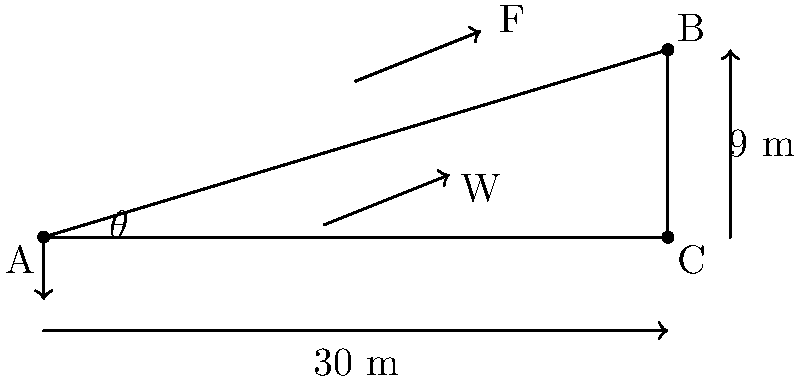You're planning to use your new tractor to plow an inclined field on your farm. The field rises 9 meters over a horizontal distance of 30 meters. Your tractor weighs 5000 kg. What minimum force (F) is required to pull the tractor up the incline at a constant speed? Assume the coefficient of friction between the tractor's wheels and the ground is 0.2, and use g = 9.8 m/s². Let's approach this step-by-step:

1) First, we need to find the angle of inclination ($\theta$):
   $\tan \theta = \frac{\text{rise}}{\text{run}} = \frac{9 \text{ m}}{30 \text{ m}} = 0.3$
   $\theta = \arctan(0.3) \approx 16.7°$

2) The weight of the tractor:
   $W = mg = 5000 \text{ kg} \times 9.8 \text{ m/s²} = 49,000 \text{ N}$

3) We can break this weight into components parallel and perpendicular to the incline:
   $W_\parallel = W \sin \theta = 49,000 \text{ N} \times \sin 16.7° \approx 14,077 \text{ N}$
   $W_\perp = W \cos \theta = 49,000 \text{ N} \times \cos 16.7° \approx 46,916 \text{ N}$

4) The friction force is:
   $f = \mu W_\perp = 0.2 \times 46,916 \text{ N} = 9,383 \text{ N}$

5) For the tractor to move at constant speed, the applied force must overcome both the component of weight parallel to the incline and the friction:
   $F = W_\parallel + f = 14,077 \text{ N} + 9,383 \text{ N} = 23,460 \text{ N}$

Therefore, the minimum force required is approximately 23,460 N.
Answer: 23,460 N 